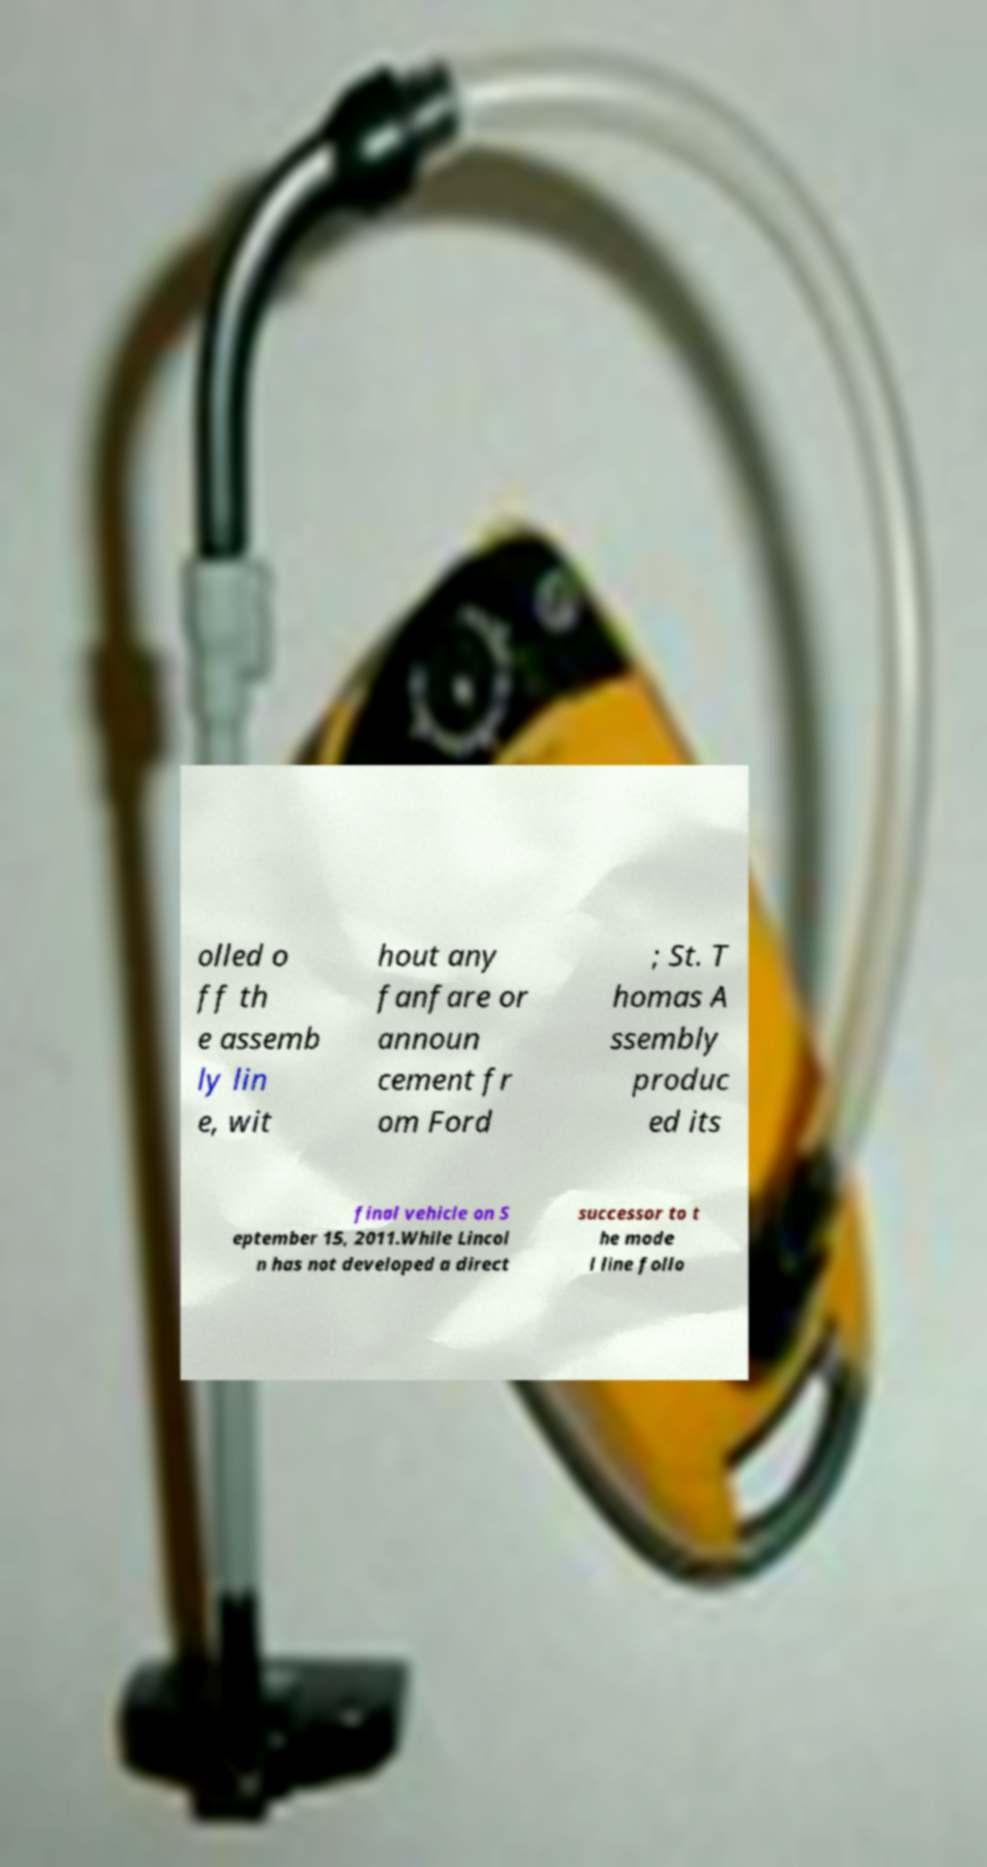Can you accurately transcribe the text from the provided image for me? olled o ff th e assemb ly lin e, wit hout any fanfare or announ cement fr om Ford ; St. T homas A ssembly produc ed its final vehicle on S eptember 15, 2011.While Lincol n has not developed a direct successor to t he mode l line follo 